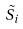Convert formula to latex. <formula><loc_0><loc_0><loc_500><loc_500>\tilde { S } _ { i }</formula> 